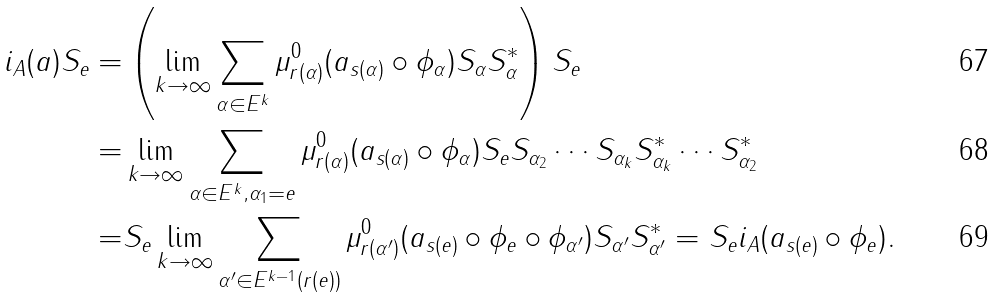<formula> <loc_0><loc_0><loc_500><loc_500>i _ { A } ( a ) S _ { e } = & \left ( \lim _ { k \rightarrow \infty } \sum _ { \alpha \in E ^ { k } } \mu _ { r ( \alpha ) } ^ { 0 } ( a _ { s ( \alpha ) } \circ \phi _ { \alpha } ) S _ { \alpha } S _ { \alpha } ^ { * } \right ) S _ { e } \\ = & \lim _ { k \rightarrow \infty } \sum _ { \alpha \in E ^ { k } , \alpha _ { 1 } = e } \mu _ { r ( \alpha ) } ^ { 0 } ( a _ { s ( \alpha ) } \circ \phi _ { \alpha } ) S _ { e } S _ { \alpha _ { 2 } } \cdots S _ { \alpha _ { k } } S _ { \alpha _ { k } } ^ { * } \cdots S _ { \alpha _ { 2 } } ^ { * } \\ = & S _ { e } \lim _ { k \rightarrow \infty } \sum _ { \alpha ^ { \prime } \in E ^ { k - 1 } ( r ( e ) ) } \mu _ { r ( \alpha ^ { \prime } ) } ^ { 0 } ( a _ { s ( e ) } \circ \phi _ { e } \circ \phi _ { \alpha ^ { \prime } } ) S _ { \alpha ^ { \prime } } S _ { \alpha ^ { \prime } } ^ { * } = S _ { e } i _ { A } ( a _ { s ( e ) } \circ \phi _ { e } ) .</formula> 